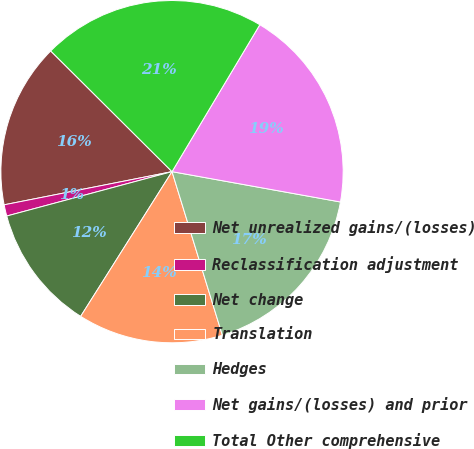<chart> <loc_0><loc_0><loc_500><loc_500><pie_chart><fcel>Net unrealized gains/(losses)<fcel>Reclassification adjustment<fcel>Net change<fcel>Translation<fcel>Hedges<fcel>Net gains/(losses) and prior<fcel>Total Other comprehensive<nl><fcel>15.56%<fcel>1.07%<fcel>11.86%<fcel>13.71%<fcel>17.41%<fcel>19.26%<fcel>21.11%<nl></chart> 